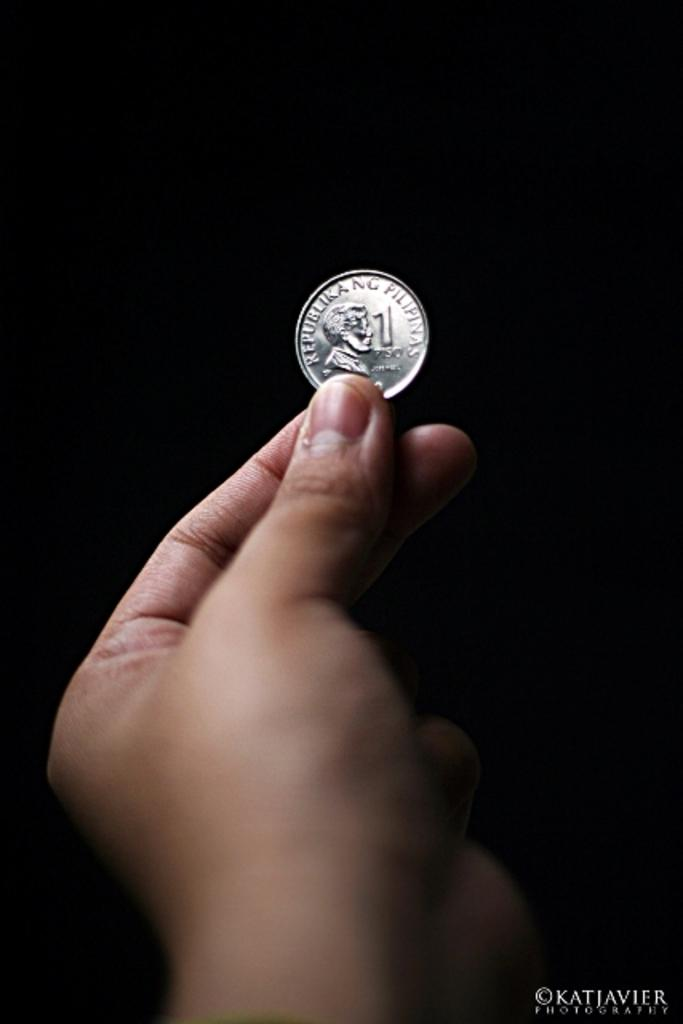What is the main subject of the image? There is a person in the image. What is the person holding in the image? The person is holding a coin. Can you describe the background of the image? The background of the image is dark. What verse can be heard being recited by the person in the image? There is no indication in the image that the person is reciting a verse, so it cannot be determined from the picture. 